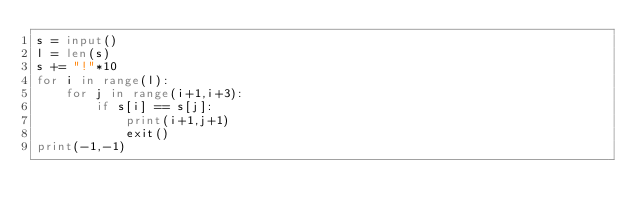Convert code to text. <code><loc_0><loc_0><loc_500><loc_500><_Python_>s = input()
l = len(s)
s += "!"*10
for i in range(l):
    for j in range(i+1,i+3):
        if s[i] == s[j]:
            print(i+1,j+1)
            exit()
print(-1,-1)</code> 